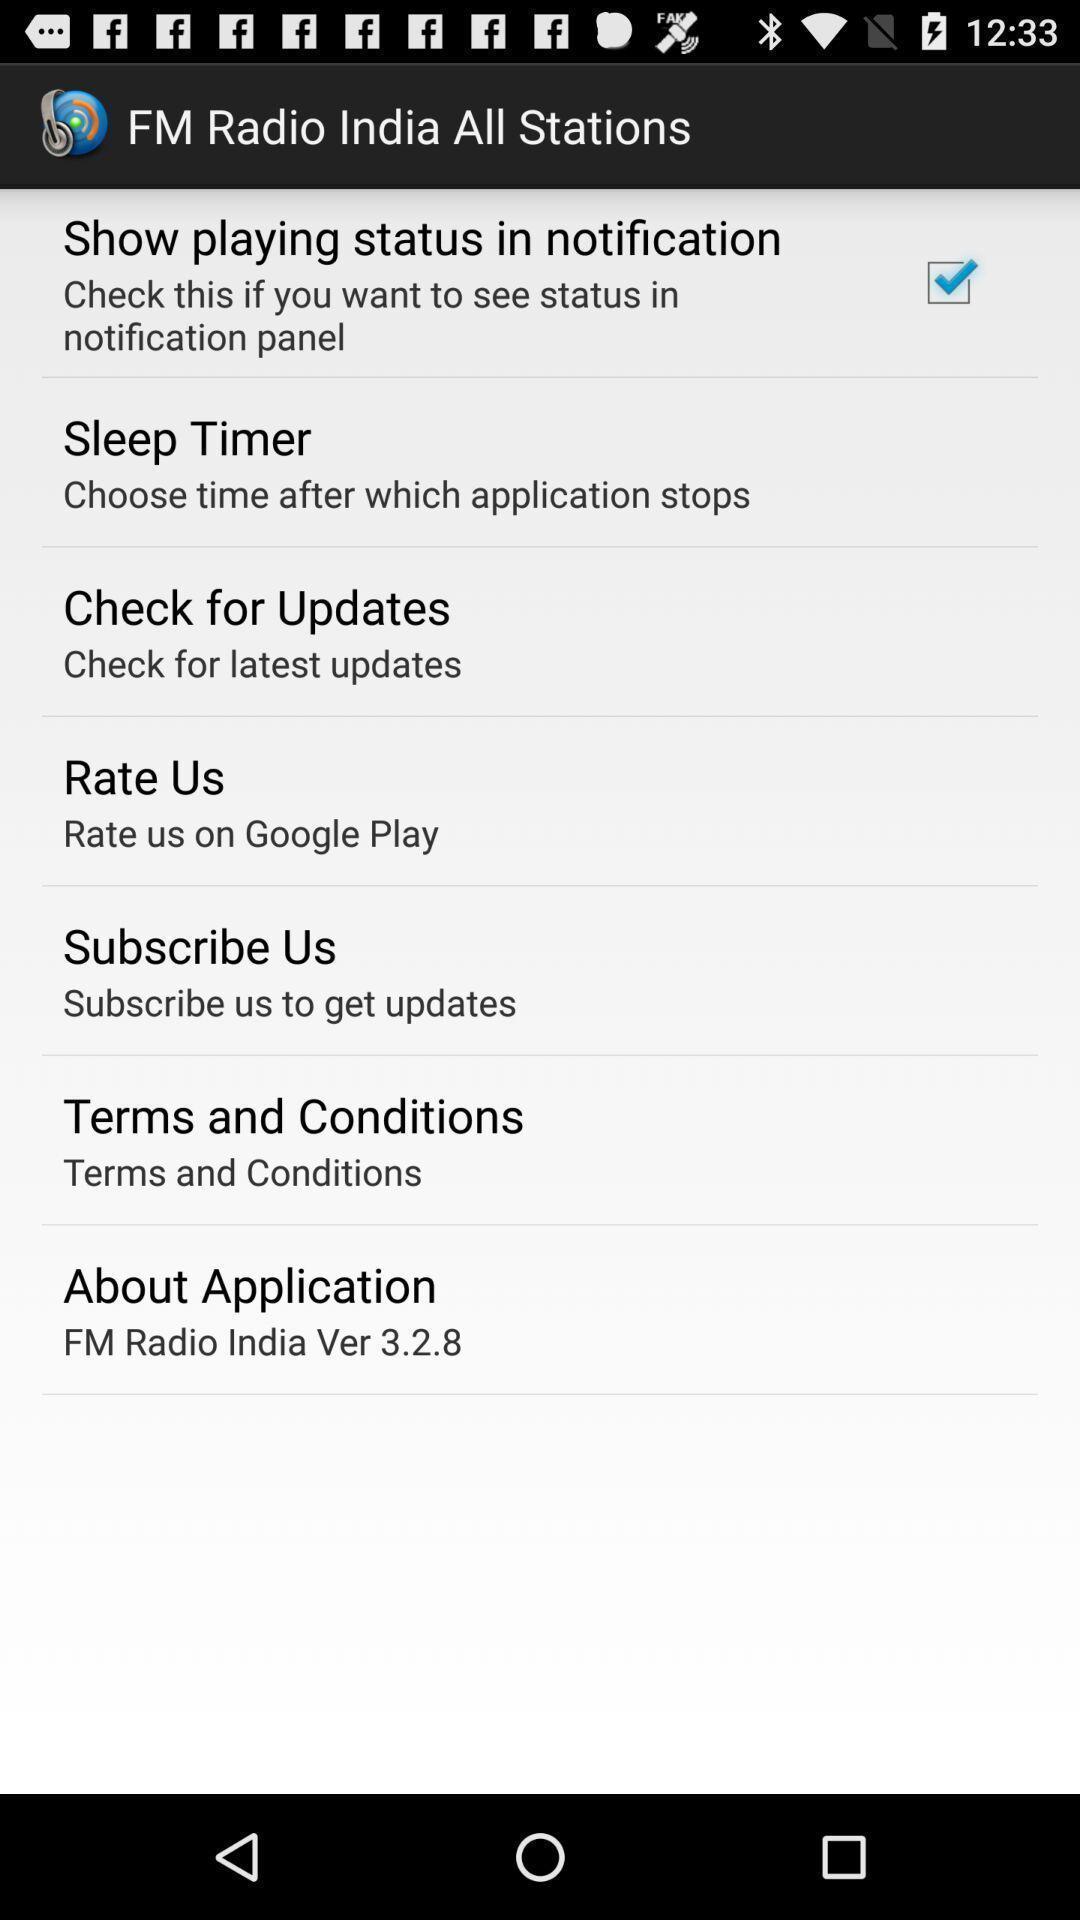Please provide a description for this image. Settings page of a radio app. 